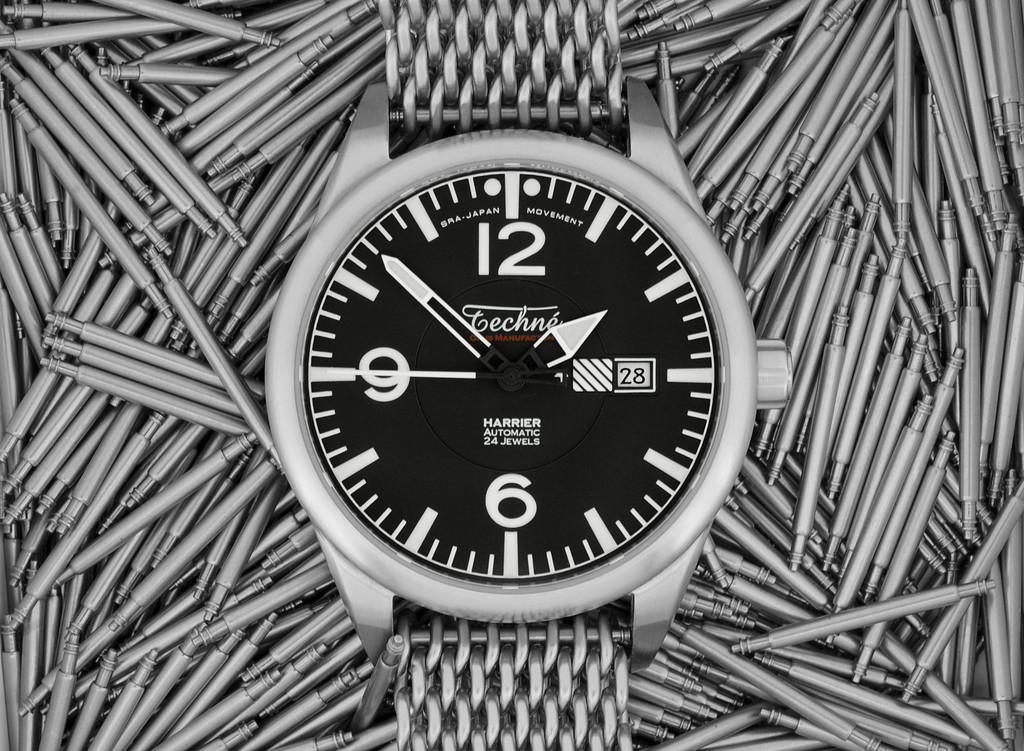What brand is the watch?
Provide a short and direct response. Techno. 